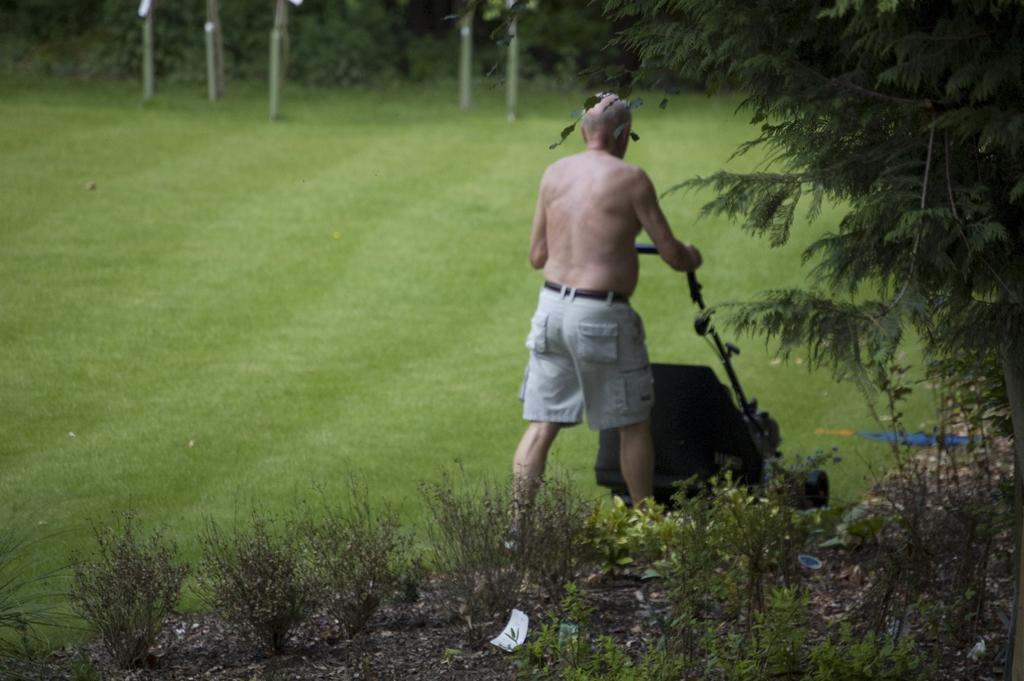Who is present in the image? There is a man in the image. What is the man holding in the image? The man is holding a lawn mower. What is the man doing in the image? The man is walking. What type of environment is depicted in the image? There is grass, plants, and trees in the image, suggesting an outdoor setting. What type of lace can be seen on the floor in the image? There is no lace present on the floor in the image. What type of writing instrument is the man using in the image? The man is not using any writing instrument in the image; he is holding a lawn mower and walking. 